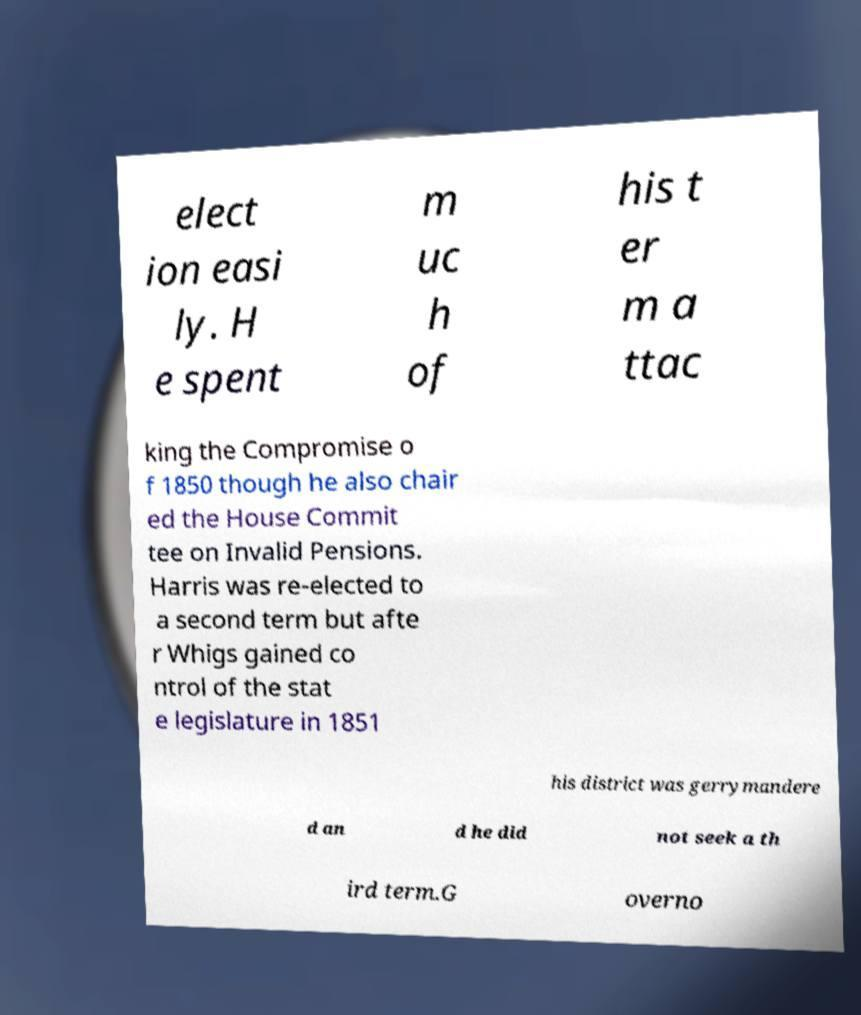There's text embedded in this image that I need extracted. Can you transcribe it verbatim? elect ion easi ly. H e spent m uc h of his t er m a ttac king the Compromise o f 1850 though he also chair ed the House Commit tee on Invalid Pensions. Harris was re-elected to a second term but afte r Whigs gained co ntrol of the stat e legislature in 1851 his district was gerrymandere d an d he did not seek a th ird term.G overno 